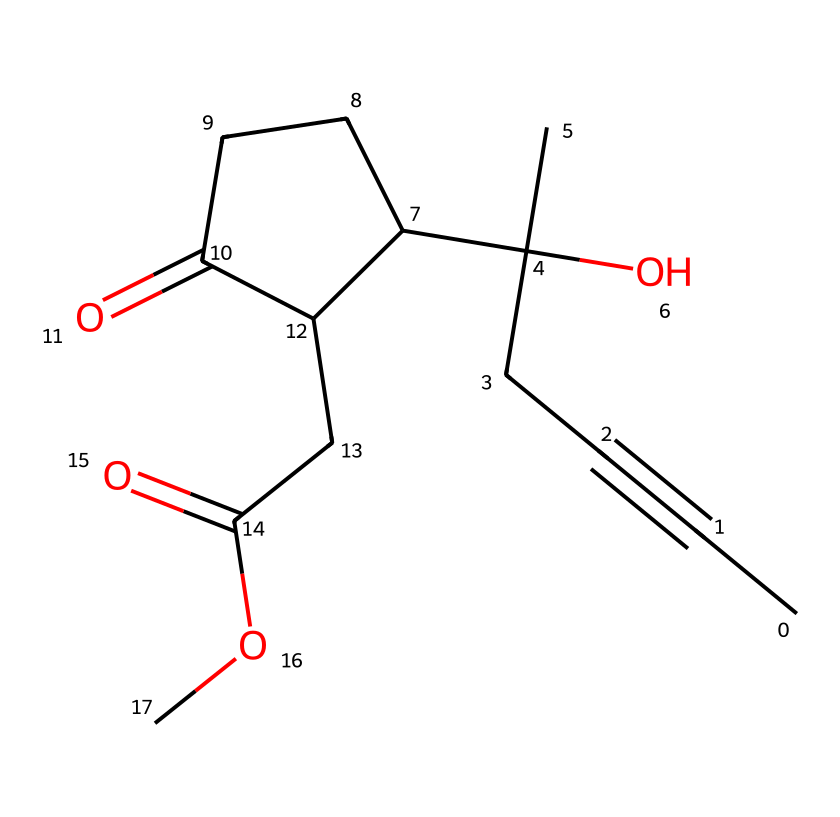How many carbon atoms are in this molecule? By analyzing the SMILES representation, we can count the carbon atoms denoted by "C" and "CC". The linear and branching structures indicate a total of 12 carbon atoms.
Answer: twelve What functional groups are present in this chemical? Looking at the SMILES, we can identify the hydroxyl group (-OH) from the "C(C)(O)" notation and the ester groups from "C(=O)OC". These indicate the presence of a hydroxyl and two ester groups.
Answer: hydroxyl and ester What is the molecular weight of this compound? To find the molecular weight, we calculate it from the counted atoms: 12 Carbon (12 g/mol) + 16 Hydrogen (1 g/mol) + 4 Oxygen (16 g/mol) totals approximately 228 g/mol.
Answer: about 228 Does this compound have a cyclic structure? In the SMILES, the notation "C1CCC(=O)C1" indicates a cyclization where the carbons form a ring. This confirms the presence of a cyclic structure in the molecule.
Answer: yes Is this compound likely to behave as a Non-Newtonian fluid? Upon evaluating its chemical structure which contains branching and functional groups, this compound shows properties that can lead to Non-Newtonian fluid behavior, particularly due to its viscous nature influenced by concentration.
Answer: yes What is the significance of the alkyne group in this structure? The presence of the alkyne group (indicated by "C#C") contributes to the reactivity as it can participate in various chemical reactions, while also affecting the overall viscosity of the compound.
Answer: increases reactivity 